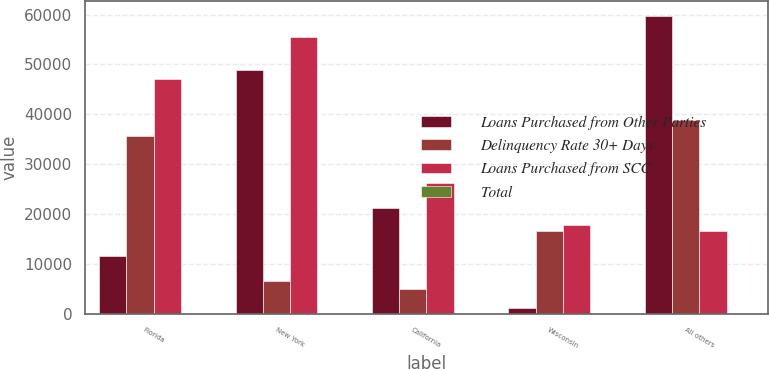<chart> <loc_0><loc_0><loc_500><loc_500><stacked_bar_chart><ecel><fcel>Florida<fcel>New York<fcel>California<fcel>Wisconsin<fcel>All others<nl><fcel>Loans Purchased from Other Parties<fcel>11538<fcel>48969<fcel>21320<fcel>1098<fcel>59708<nl><fcel>Delinquency Rate 30+ Days<fcel>35591<fcel>6561<fcel>4999<fcel>16641<fcel>38791<nl><fcel>Loans Purchased from SCC<fcel>47129<fcel>55530<fcel>26319<fcel>17739<fcel>16641<nl><fcel>Total<fcel>19<fcel>23<fcel>11<fcel>7<fcel>40<nl></chart> 